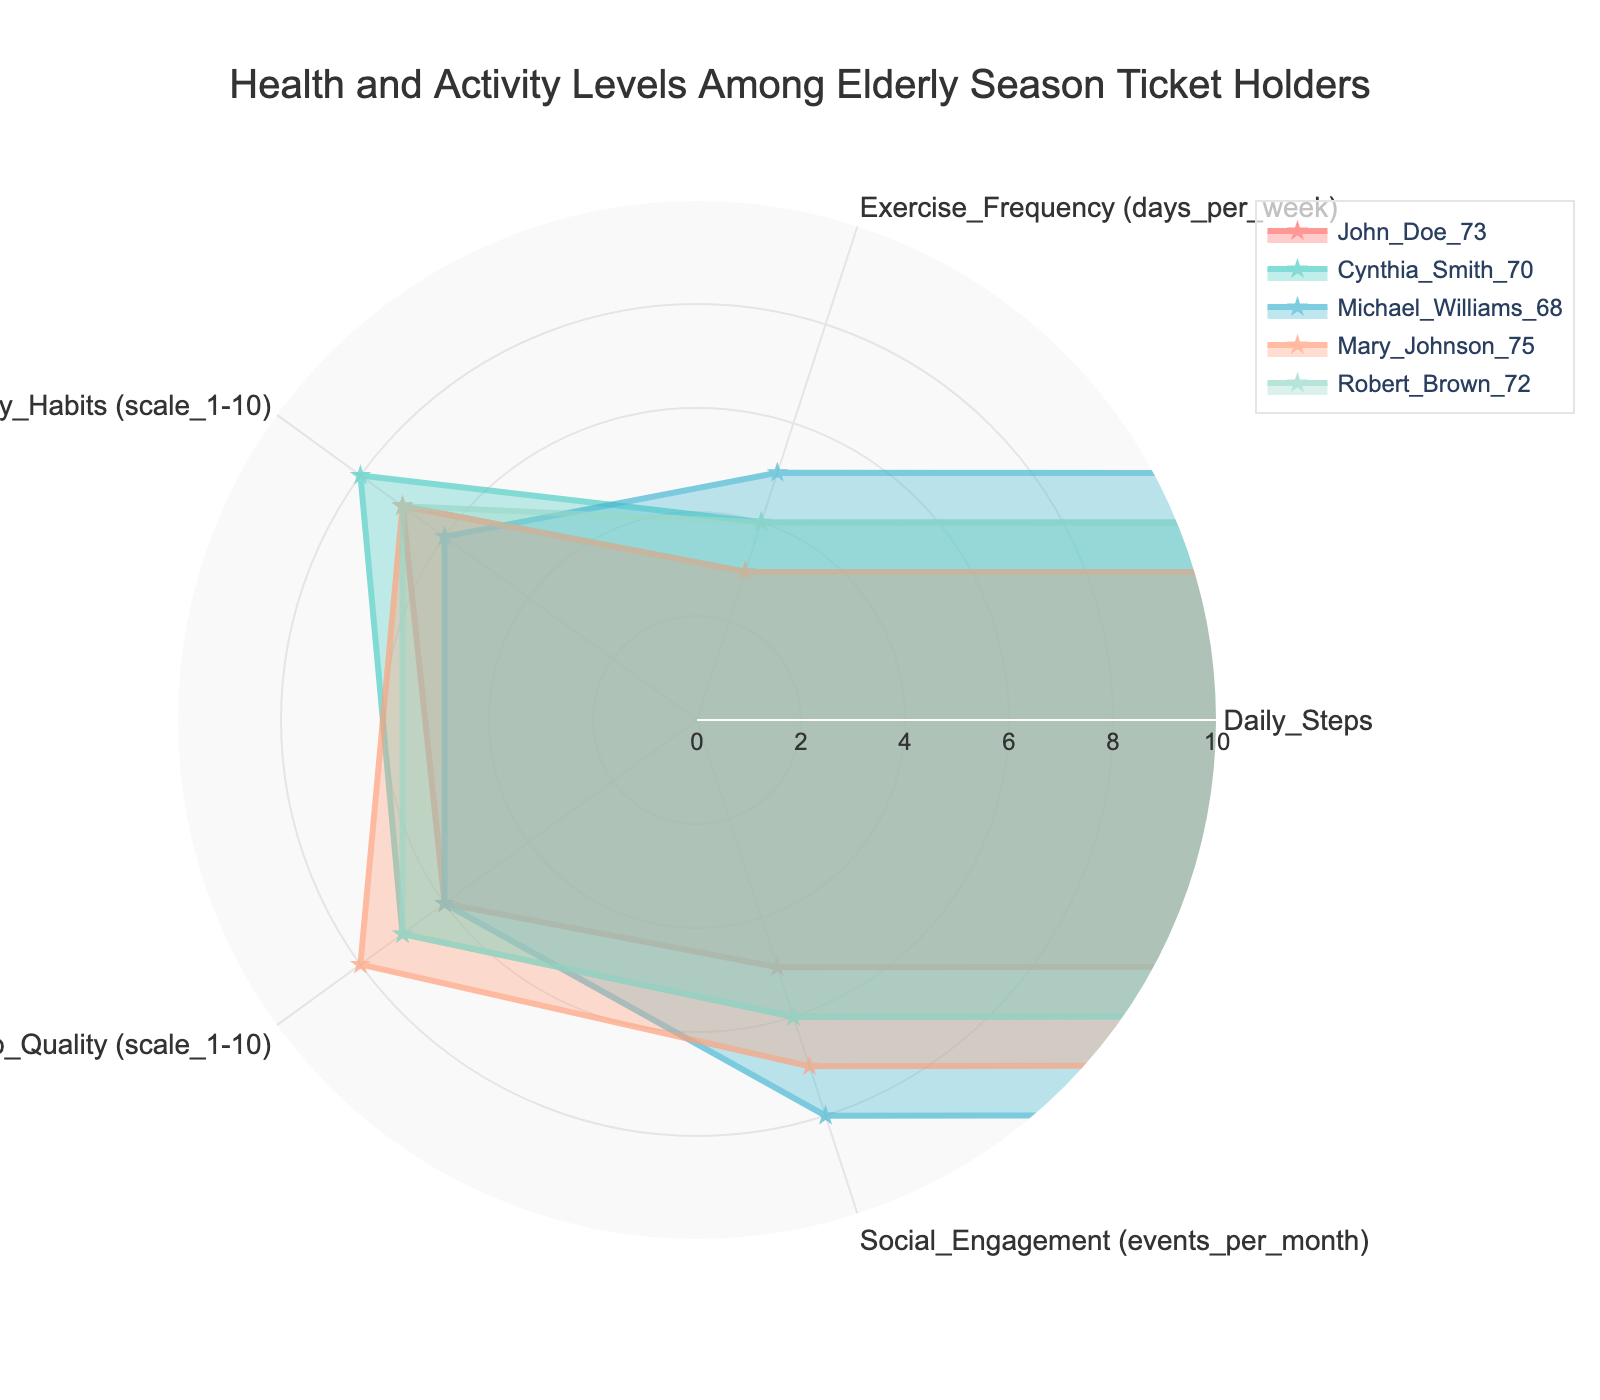What's the title of the radar chart? The title is usually located at the top center of the chart and provides a summary of what the chart represents.
Answer: Health and Activity Levels Among Elderly Season Ticket Holders How many categories are there in the chart? The categories are the different axes on the radar chart. Counting them shows how many aspects are being evaluated.
Answer: 5 Which individual has the highest value for Exercise Frequency? Look for the polygon that extends the farthest along the "Exercise Frequency" axis.
Answer: Michael Williams What is the range of values for the radial axis? The chart's radial axis range can be determined by looking for the labeled numeric values on the chart.
Answer: 0 to 10 Who has the lowest Rest and Sleep Quality? Identify the polygon with the smallest value along the "Rest and Sleep Quality" axis.
Answer: John Doe and Michael Williams (both with a score of 6) Which individual has the highest average score across all categories? Sum the values for each individual, then divide by the number of categories to find the average.
Answer: Cynthia Smith Compare the Daily Steps of Mary Johnson and Robert Brown. Who takes more steps daily? Look for the values on the "Daily Steps" axis for both individuals and compare the lengths.
Answer: Robert Brown What is the total number of social engagement events per month for Robert Brown? The value on the "Social Engagement" axis for Robert Brown corresponds to the number of events per month. No calculation needed in this case.
Answer: 6 Who has the highest dietary habits score and what is it? Find the highest value along the "Dietary Habits" axis and note the corresponding individual.
Answer: Cynthia Smith (8) How many people exercise at least 4 days per week? Locate and count polygons extending to 4 or beyond on the "Exercise Frequency" axis.
Answer: 3 (Cynthia Smith, Michael Williams, Robert Brown) 